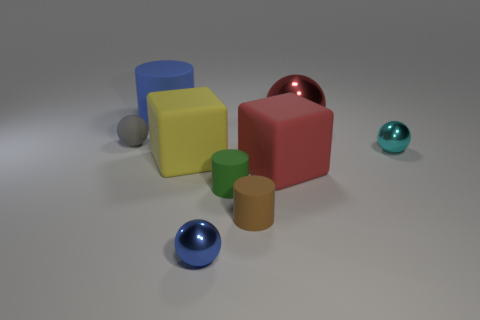Subtract all red balls. How many balls are left? 3 Subtract all blue metal spheres. How many spheres are left? 3 Subtract all green spheres. Subtract all cyan blocks. How many spheres are left? 4 Add 1 brown rubber objects. How many objects exist? 10 Subtract all blocks. How many objects are left? 7 Add 9 tiny blue metal things. How many tiny blue metal things exist? 10 Subtract 1 blue spheres. How many objects are left? 8 Subtract all big rubber cylinders. Subtract all shiny things. How many objects are left? 5 Add 8 large yellow cubes. How many large yellow cubes are left? 9 